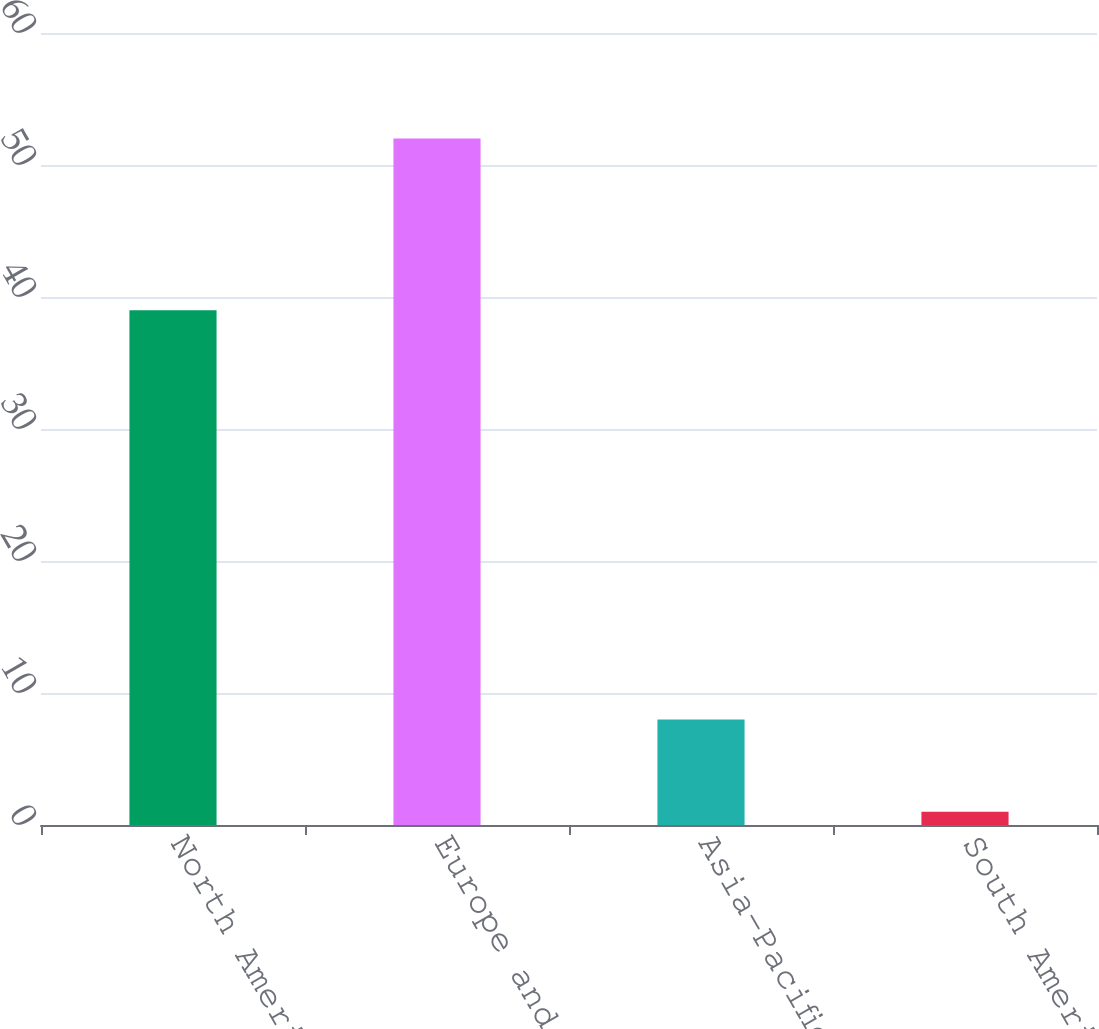Convert chart. <chart><loc_0><loc_0><loc_500><loc_500><bar_chart><fcel>North America<fcel>Europe and Africa<fcel>Asia-Pacific<fcel>South America<nl><fcel>39<fcel>52<fcel>8<fcel>1<nl></chart> 